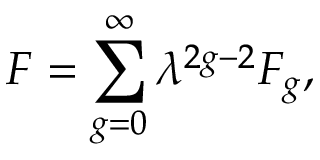<formula> <loc_0><loc_0><loc_500><loc_500>F = \sum _ { g = 0 } ^ { \infty } \lambda ^ { 2 g - 2 } F _ { g } ,</formula> 